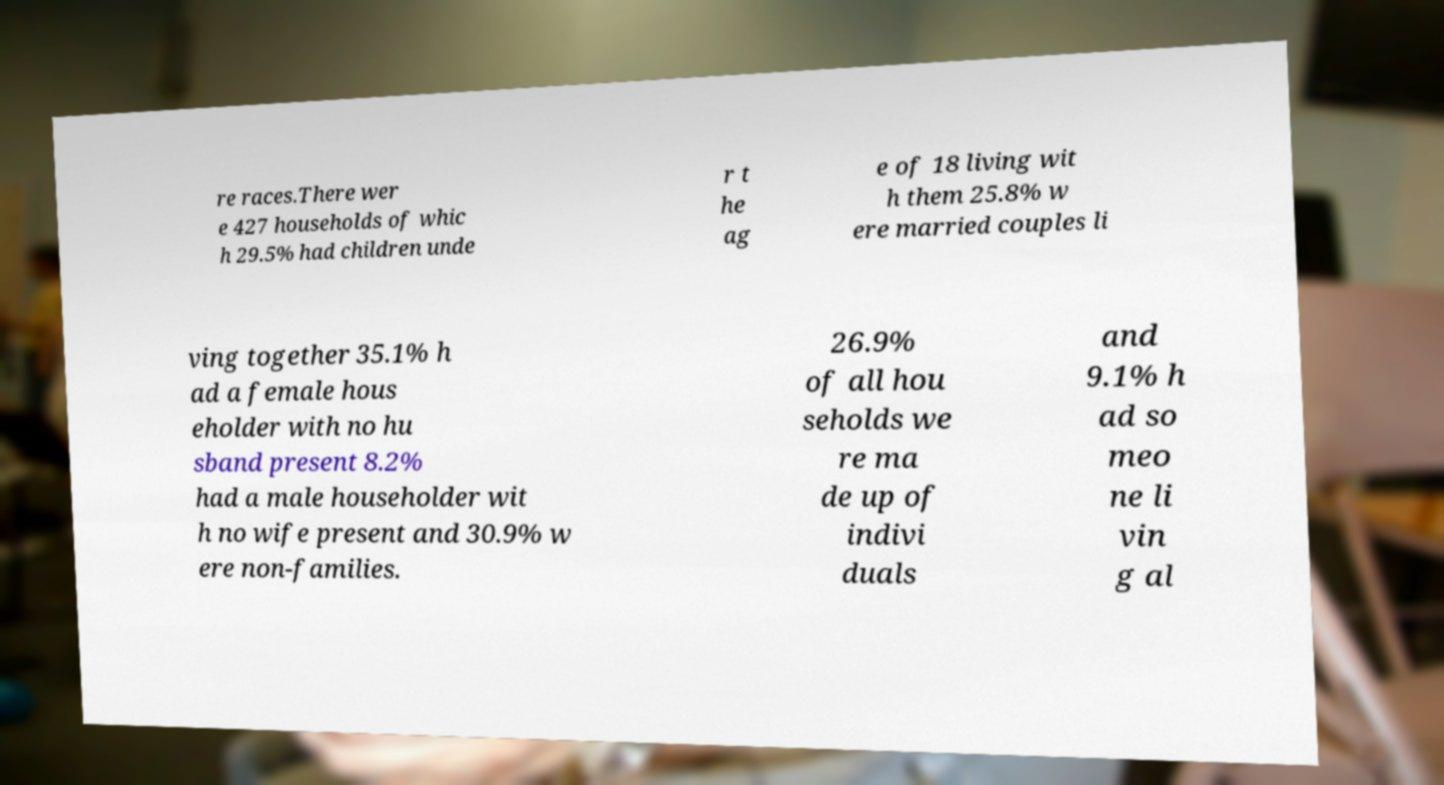Please read and relay the text visible in this image. What does it say? re races.There wer e 427 households of whic h 29.5% had children unde r t he ag e of 18 living wit h them 25.8% w ere married couples li ving together 35.1% h ad a female hous eholder with no hu sband present 8.2% had a male householder wit h no wife present and 30.9% w ere non-families. 26.9% of all hou seholds we re ma de up of indivi duals and 9.1% h ad so meo ne li vin g al 